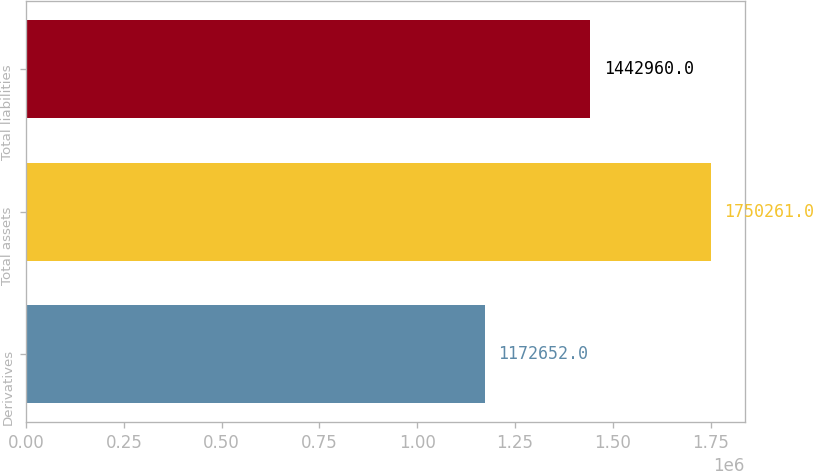Convert chart to OTSL. <chart><loc_0><loc_0><loc_500><loc_500><bar_chart><fcel>Derivatives<fcel>Total assets<fcel>Total liabilities<nl><fcel>1.17265e+06<fcel>1.75026e+06<fcel>1.44296e+06<nl></chart> 